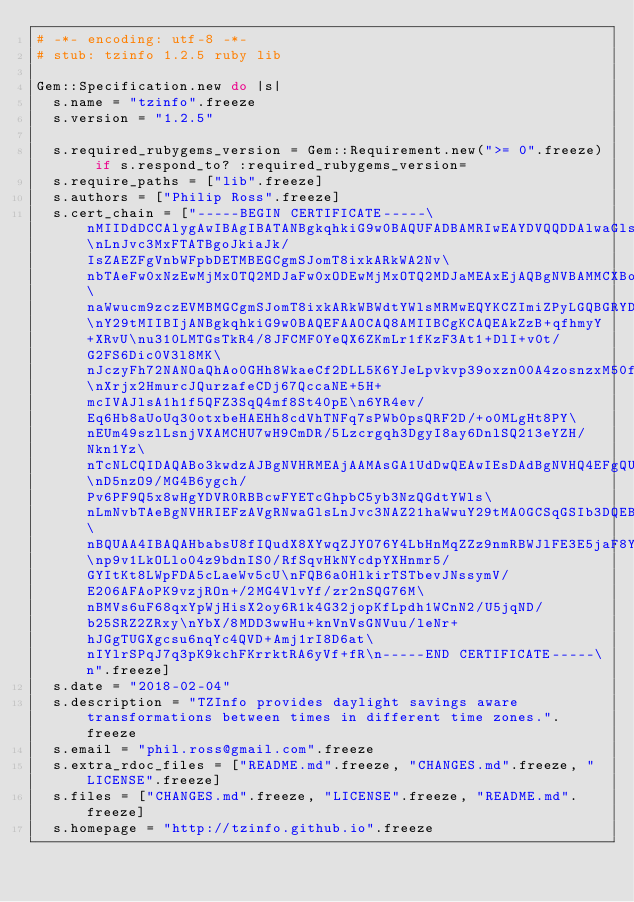<code> <loc_0><loc_0><loc_500><loc_500><_Ruby_># -*- encoding: utf-8 -*-
# stub: tzinfo 1.2.5 ruby lib

Gem::Specification.new do |s|
  s.name = "tzinfo".freeze
  s.version = "1.2.5"

  s.required_rubygems_version = Gem::Requirement.new(">= 0".freeze) if s.respond_to? :required_rubygems_version=
  s.require_paths = ["lib".freeze]
  s.authors = ["Philip Ross".freeze]
  s.cert_chain = ["-----BEGIN CERTIFICATE-----\nMIIDdDCCAlygAwIBAgIBATANBgkqhkiG9w0BAQUFADBAMRIwEAYDVQQDDAlwaGls\nLnJvc3MxFTATBgoJkiaJk/IsZAEZFgVnbWFpbDETMBEGCgmSJomT8ixkARkWA2Nv\nbTAeFw0xNzEwMjMxOTQ2MDJaFw0xODEwMjMxOTQ2MDJaMEAxEjAQBgNVBAMMCXBo\naWwucm9zczEVMBMGCgmSJomT8ixkARkWBWdtYWlsMRMwEQYKCZImiZPyLGQBGRYD\nY29tMIIBIjANBgkqhkiG9w0BAQEFAAOCAQ8AMIIBCgKCAQEAkZzB+qfhmyY+XRvU\nu310LMTGsTkR4/8JFCMF0YeQX6ZKmLr1fKzF3At1+DlI+v0t/G2FS6Dic0V3l8MK\nJczyFh72NANOaQhAo0GHh8WkaeCf2DLL5K6YJeLpvkvp39oxzn00A4zosnzxM50f\nXrjx2HmurcJQurzafeCDj67QccaNE+5H+mcIVAJlsA1h1f5QFZ3SqQ4mf8St40pE\n6YR4ev/Eq6Hb8aUoUq30otxbeHAEHh8cdVhTNFq7sPWb0psQRF2D/+o0MLgHt8PY\nEUm49szlLsnjVXAMCHU7wH9CmDR/5Lzcrgqh3DgyI8ay6DnlSQ213eYZH/Nkn1Yz\nTcNLCQIDAQABo3kwdzAJBgNVHRMEAjAAMAsGA1UdDwQEAwIEsDAdBgNVHQ4EFgQU\nD5nzO9/MG4B6ygch/Pv6PF9Q5x8wHgYDVR0RBBcwFYETcGhpbC5yb3NzQGdtYWls\nLmNvbTAeBgNVHRIEFzAVgRNwaGlsLnJvc3NAZ21haWwuY29tMA0GCSqGSIb3DQEB\nBQUAA4IBAQAHbabsU8fIQudX8XYwqZJYO76Y4LbHnMqZZz9nmRBWJlFE3E5jaF8Y\np9v1LkOLlo04z9bdnIS0/RfSqvHkNYcdpYXHnmr5/GYItKt8LWpFDA5cLaeWv5cU\nFQB6a0HlkirTSTbevJNssymV/E206AFAoPK9vzjROn+/2MG4VlvYf/zr2nSQG76M\nBMVs6uF68qxYpWjHisX2oy6R1k4G32jopKfLpdh1WCnN2/U5jqND/b25SRZ2ZRxy\nYbX/8MDD3wwHu+knVnVsGNVuu/leNr+hJGgTUGXgcsu6nqYc4QVD+Amj1rI8D6at\nIYlrSPqJ7q3pK9kchFKrrktRA6yVf+fR\n-----END CERTIFICATE-----\n".freeze]
  s.date = "2018-02-04"
  s.description = "TZInfo provides daylight savings aware transformations between times in different time zones.".freeze
  s.email = "phil.ross@gmail.com".freeze
  s.extra_rdoc_files = ["README.md".freeze, "CHANGES.md".freeze, "LICENSE".freeze]
  s.files = ["CHANGES.md".freeze, "LICENSE".freeze, "README.md".freeze]
  s.homepage = "http://tzinfo.github.io".freeze</code> 